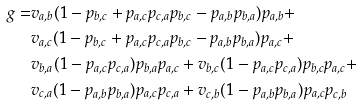Convert formula to latex. <formula><loc_0><loc_0><loc_500><loc_500>g = & v _ { a , b } ( 1 - p _ { b , c } + p _ { a , c } p _ { c , a } p _ { b , c } - p _ { a , b } p _ { b , a } ) p _ { a , b } + \\ & v _ { a , c } ( 1 - p _ { b , c } + p _ { a , c } p _ { c , a } p _ { b , c } - p _ { a , b } p _ { b , a } ) p _ { a , c } + \\ & v _ { b , a } ( 1 - p _ { a , c } p _ { c , a } ) p _ { b , a } p _ { a , c } + v _ { b , c } ( 1 - p _ { a , c } p _ { c , a } ) p _ { b , c } p _ { a , c } + \\ & v _ { c , a } ( 1 - p _ { a , b } p _ { b , a } ) p _ { a , c } p _ { c , a } + v _ { c , b } ( 1 - p _ { a , b } p _ { b , a } ) p _ { a , c } p _ { c , b }</formula> 